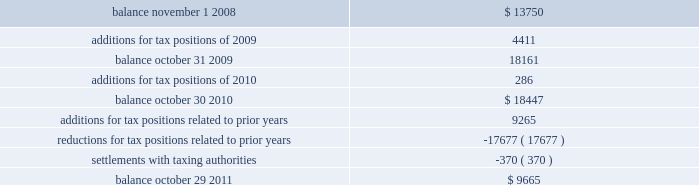The table summarizes the changes in the total amounts of unrealized tax benefits for fiscal 2009 through fiscal 2011. .
Fiscal years 2004 and 2005 irs examination during the fourth quarter of fiscal 2007 , the internal revenue service ( irs ) completed its field examination of the company 2019s fiscal years 2004 and 2005 .
On january 2 , 2008 , the irs issued its report for fiscal 2004 and 2005 , which included four proposed adjustments related to these two fiscal years that the company protested to the irs appeals office .
Two of the unresolved matters were one-time issues that pertain to section 965 of the internal revenue code related to the beneficial tax treatment of dividends paid from foreign owned companies under the american jobs creation act .
The other matters pertained to the computation of the research and development ( r&d ) tax credit and certain profits earned from manufacturing activities carried on outside the united states .
The company recorded a tax liability for a portion of the proposed r&d tax credit adjustment .
These four items had an additional potential tax liability of $ 46 million .
The company concluded , based on discussions with its tax advisors , that these items were not likely to result in any additional tax liability .
Therefore , the company did not record a tax liability for these items .
During the second quarter of fiscal 2011 , the company reached settlement with the irs appeals office on three of the four items under protest .
The remaining unresolved matter is a one-time issue pertaining to section 965 of the internal revenue code related to the beneficial tax treatment of dividends from foreign owned companies under the american jobs creation act .
The company will file a petition with the tax court with respect to this open matter .
The potential liability for this adjustment is $ 36.5 million .
The company has concluded , based on discussions with its tax advisors , that this item is not likely to result in any additional tax liability .
Therefore , the company has not recorded any additional tax liability for this issue .
Fiscal years 2006 and 2007 irs examination during the third quarter of fiscal 2009 , the irs completed its field examination of the company 2019s fiscal years 2006 and 2007 .
The irs and the company agreed on the treatment of a number of issues that have been included in an issue resolutions agreement related to the 2006 and 2007 tax returns .
However , no agreement was reached on the tax treatment of a number of issues for the fiscal 2006 and fiscal 2007 years , including the same r&d tax credit and foreign manufacturing issues mentioned above related to fiscal 2004 and 2005 , the pricing of intercompany sales ( transfer pricing ) and the deductibility of certain stock option compensation expenses .
The company recorded taxes related to a portion of the proposed r&d tax credit adjustment .
These four items had an additional potential total tax liability of $ 195 million .
The company concluded , based on discussions with its tax advisors that these items were not likely to result in any additional tax liability .
Therefore , the company did not record any additional tax liability for these items and appealed these proposed adjustments through the normal processes for the resolution of differences between the irs and taxpayers .
During the second quarter of fiscal 2011 , the company reached an agreement with the irs appeals office on three of the four protested items , two of which were the same issues settled relating to the 2004 and 2005 fiscal years .
Transfer pricing remained as the only item under protest with the irs appeals office related to the fiscal analog devices , inc .
Notes to consolidated financial statements 2014 ( continued ) .
What is the net change in unrealized tax benefits during 2010? 
Computations: ((9265 + -17677) + -370)
Answer: -8782.0. 